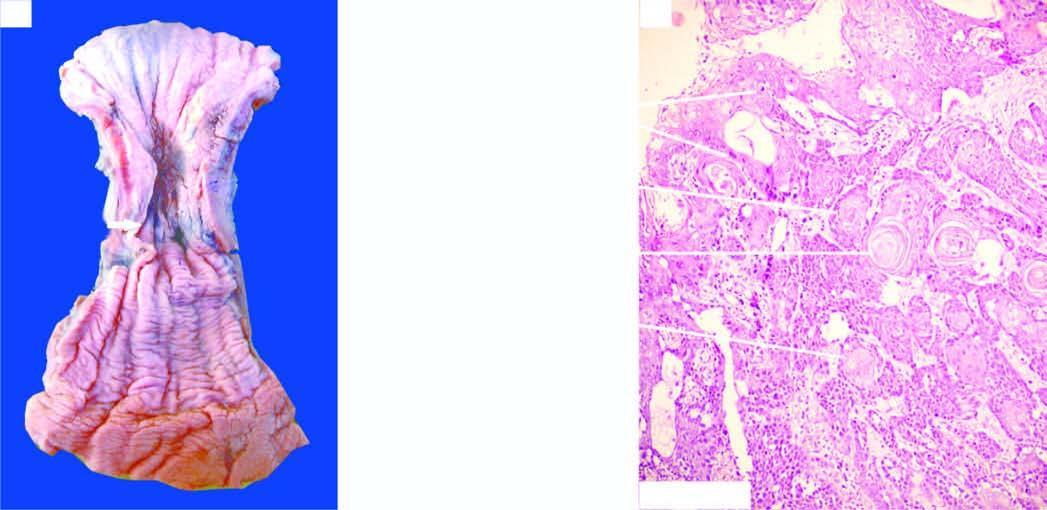does photomicrograph show whorls of anaplastic squamous cells invading the underlying soft tissues?
Answer the question using a single word or phrase. Yes 